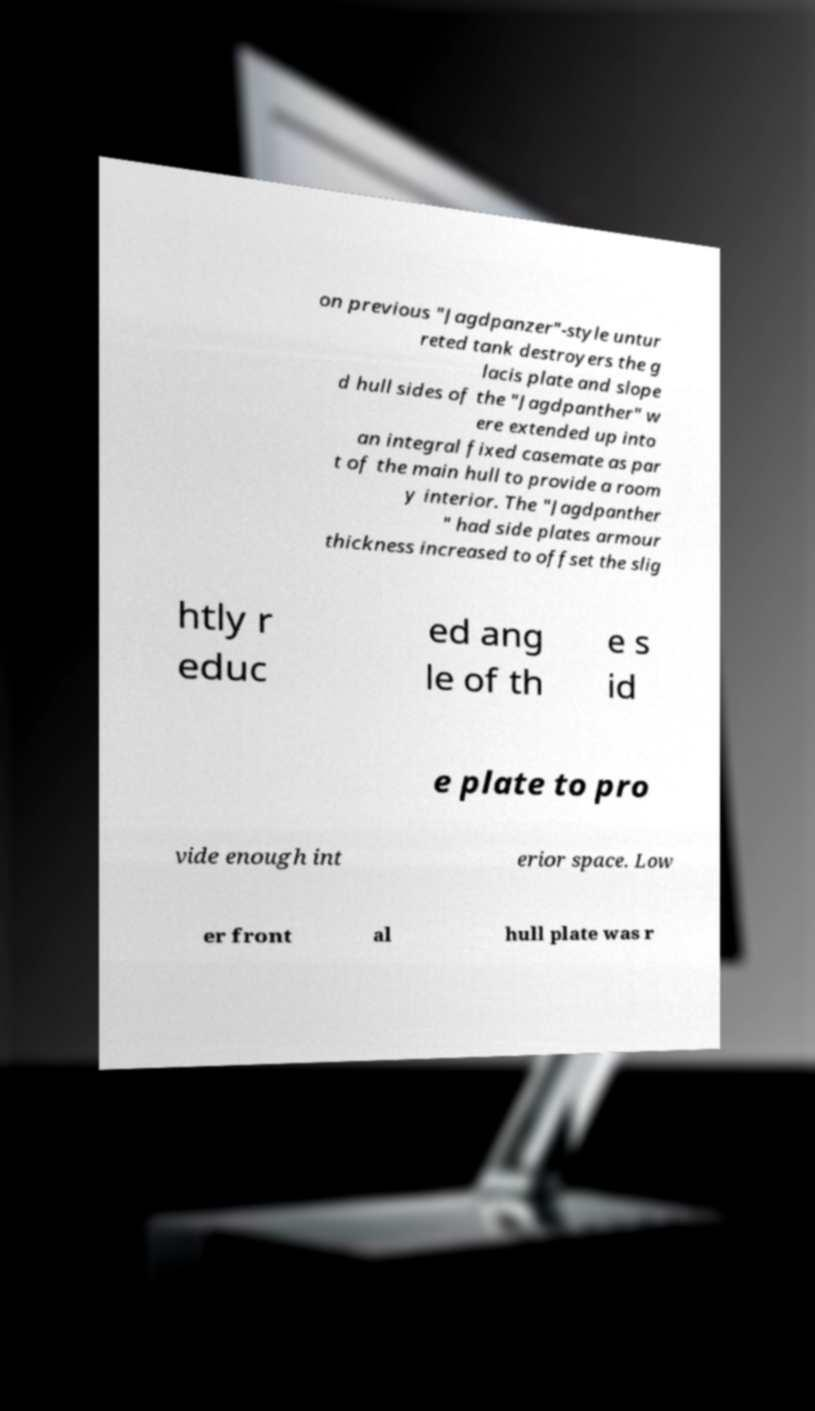Could you assist in decoding the text presented in this image and type it out clearly? on previous "Jagdpanzer"-style untur reted tank destroyers the g lacis plate and slope d hull sides of the "Jagdpanther" w ere extended up into an integral fixed casemate as par t of the main hull to provide a room y interior. The "Jagdpanther " had side plates armour thickness increased to offset the slig htly r educ ed ang le of th e s id e plate to pro vide enough int erior space. Low er front al hull plate was r 